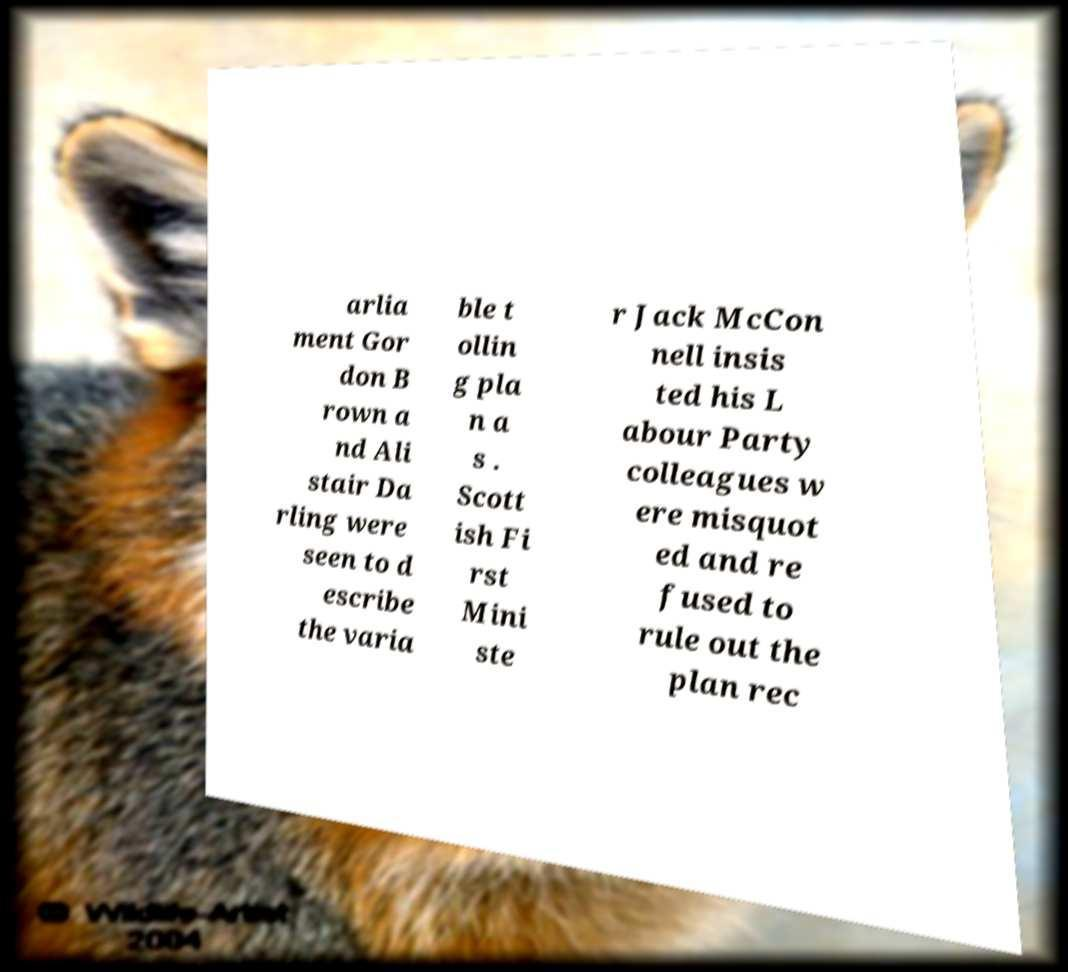Could you extract and type out the text from this image? arlia ment Gor don B rown a nd Ali stair Da rling were seen to d escribe the varia ble t ollin g pla n a s . Scott ish Fi rst Mini ste r Jack McCon nell insis ted his L abour Party colleagues w ere misquot ed and re fused to rule out the plan rec 